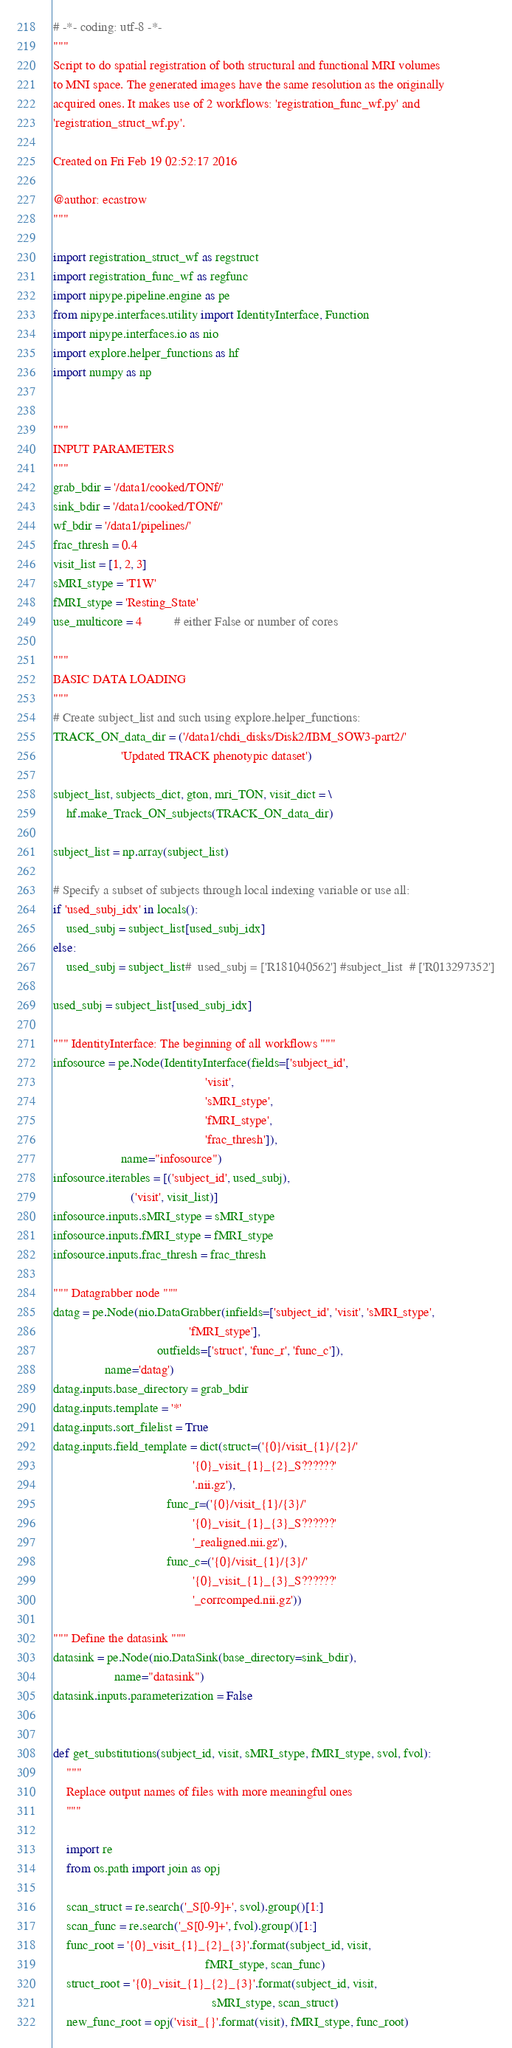Convert code to text. <code><loc_0><loc_0><loc_500><loc_500><_Python_># -*- coding: utf-8 -*-
"""
Script to do spatial registration of both structural and functional MRI volumes
to MNI space. The generated images have the same resolution as the originally
acquired ones. It makes use of 2 workflows: 'registration_func_wf.py' and
'registration_struct_wf.py'.

Created on Fri Feb 19 02:52:17 2016

@author: ecastrow
"""

import registration_struct_wf as regstruct
import registration_func_wf as regfunc
import nipype.pipeline.engine as pe
from nipype.interfaces.utility import IdentityInterface, Function
import nipype.interfaces.io as nio
import explore.helper_functions as hf
import numpy as np


"""
INPUT PARAMETERS
"""
grab_bdir = '/data1/cooked/TONf/'
sink_bdir = '/data1/cooked/TONf/'
wf_bdir = '/data1/pipelines/'
frac_thresh = 0.4
visit_list = [1, 2, 3]
sMRI_stype = 'T1W'
fMRI_stype = 'Resting_State'
use_multicore = 4          # either False or number of cores

"""
BASIC DATA LOADING
"""
# Create subject_list and such using explore.helper_functions:
TRACK_ON_data_dir = ('/data1/chdi_disks/Disk2/IBM_SOW3-part2/'
                     'Updated TRACK phenotypic dataset')

subject_list, subjects_dict, gton, mri_TON, visit_dict = \
    hf.make_Track_ON_subjects(TRACK_ON_data_dir)

subject_list = np.array(subject_list)

# Specify a subset of subjects through local indexing variable or use all:
if 'used_subj_idx' in locals():
    used_subj = subject_list[used_subj_idx]
else:
    used_subj = subject_list#  used_subj = ['R181040562'] #subject_list  # ['R013297352']

used_subj = subject_list[used_subj_idx]

""" IdentityInterface: The beginning of all workflows """
infosource = pe.Node(IdentityInterface(fields=['subject_id',
                                               'visit',
                                               'sMRI_stype',
                                               'fMRI_stype',
                                               'frac_thresh']),
                     name="infosource")
infosource.iterables = [('subject_id', used_subj),
                        ('visit', visit_list)]
infosource.inputs.sMRI_stype = sMRI_stype
infosource.inputs.fMRI_stype = fMRI_stype
infosource.inputs.frac_thresh = frac_thresh

""" Datagrabber node """
datag = pe.Node(nio.DataGrabber(infields=['subject_id', 'visit', 'sMRI_stype',
                                          'fMRI_stype'],
                                outfields=['struct', 'func_r', 'func_c']),
                name='datag')
datag.inputs.base_directory = grab_bdir
datag.inputs.template = '*'
datag.inputs.sort_filelist = True
datag.inputs.field_template = dict(struct=('{0}/visit_{1}/{2}/'
                                           '{0}_visit_{1}_{2}_S??????'
                                           '.nii.gz'),
                                   func_r=('{0}/visit_{1}/{3}/'
                                           '{0}_visit_{1}_{3}_S??????'
                                           '_realigned.nii.gz'),
                                   func_c=('{0}/visit_{1}/{3}/'
                                           '{0}_visit_{1}_{3}_S??????'
                                           '_corrcomped.nii.gz'))

""" Define the datasink """
datasink = pe.Node(nio.DataSink(base_directory=sink_bdir),
                   name="datasink")
datasink.inputs.parameterization = False


def get_substitutions(subject_id, visit, sMRI_stype, fMRI_stype, svol, fvol):
    """
    Replace output names of files with more meaningful ones
    """

    import re
    from os.path import join as opj

    scan_struct = re.search('_S[0-9]+', svol).group()[1:]
    scan_func = re.search('_S[0-9]+', fvol).group()[1:]
    func_root = '{0}_visit_{1}_{2}_{3}'.format(subject_id, visit,
                                               fMRI_stype, scan_func)
    struct_root = '{0}_visit_{1}_{2}_{3}'.format(subject_id, visit,
                                                 sMRI_stype, scan_struct)
    new_func_root = opj('visit_{}'.format(visit), fMRI_stype, func_root)</code> 